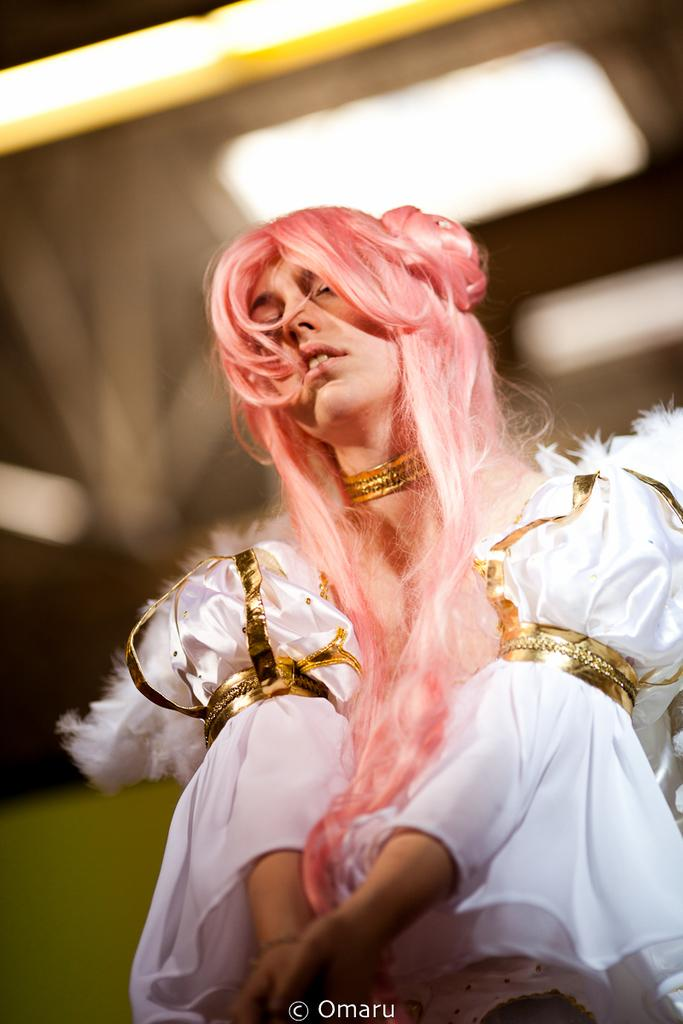Who is the main subject in the image? There is a woman in the image. What is the woman wearing? The woman is wearing a white dress. What is unique about the woman's appearance? The woman has pink hair. What type of legal advice is the woman providing in the image? There is no indication in the image that the woman is providing legal advice or acting as a lawyer. 